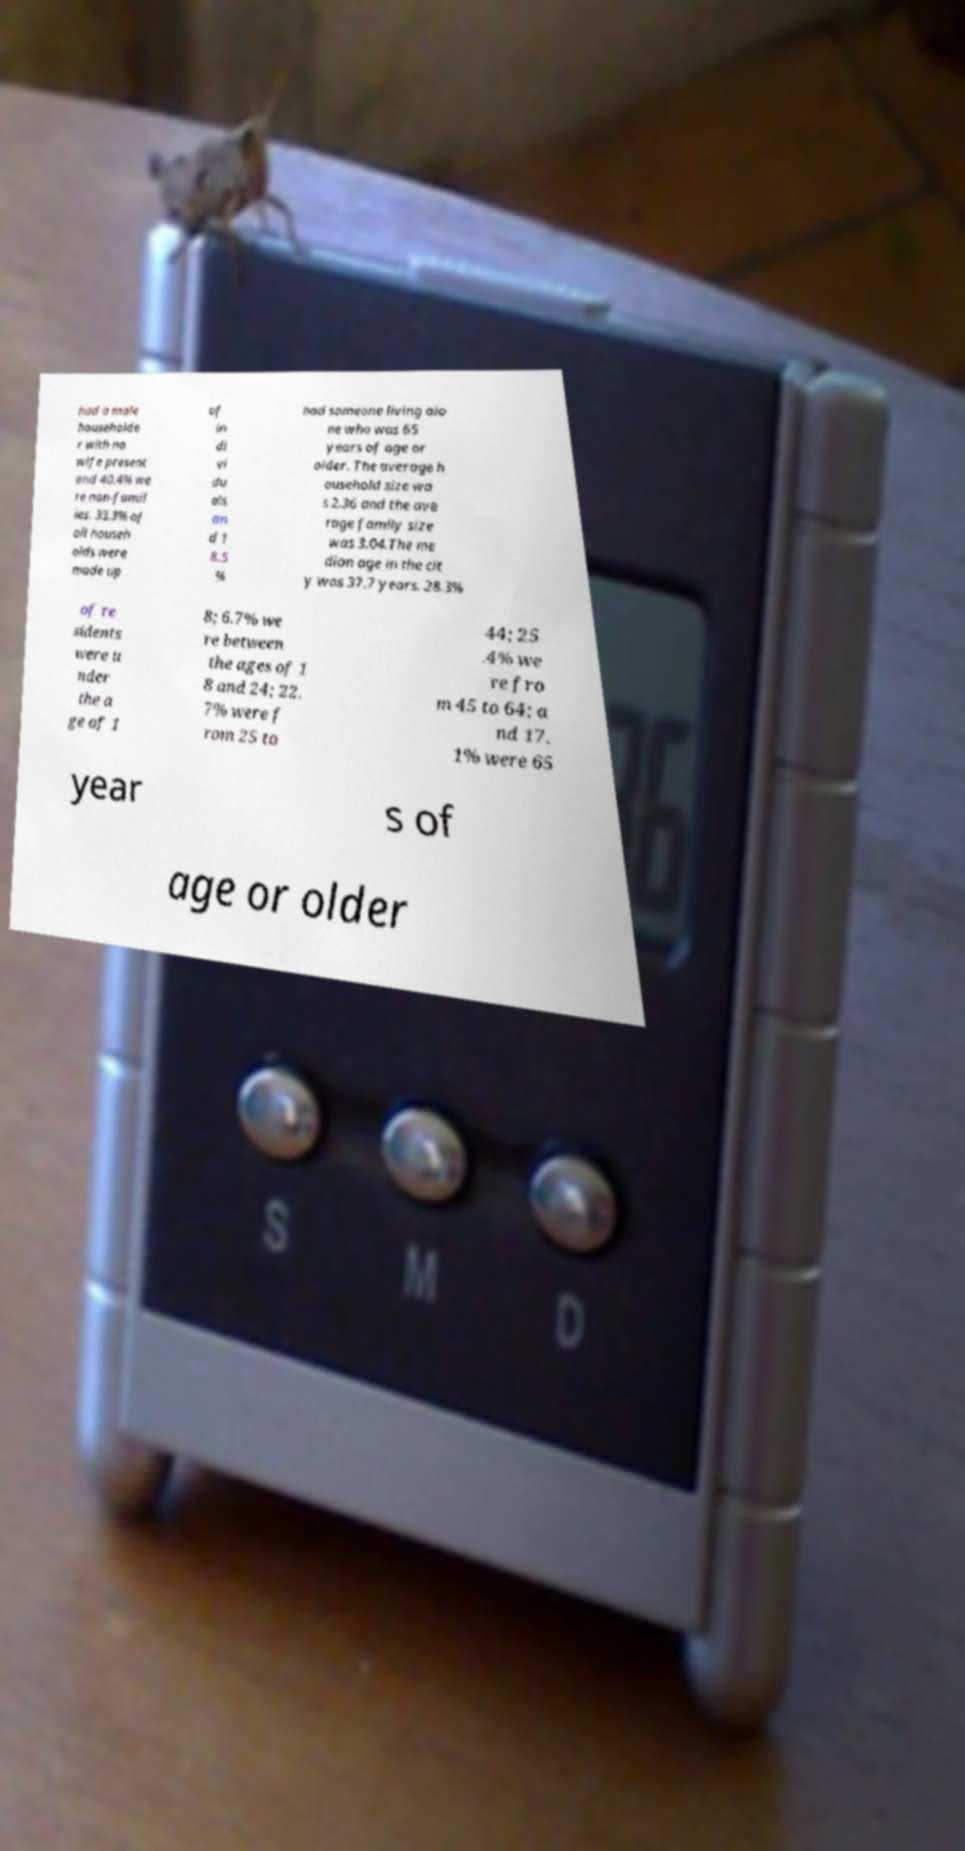I need the written content from this picture converted into text. Can you do that? had a male householde r with no wife present and 40.4% we re non-famil ies. 33.3% of all househ olds were made up of in di vi du als an d 1 8.5 % had someone living alo ne who was 65 years of age or older. The average h ousehold size wa s 2.36 and the ave rage family size was 3.04.The me dian age in the cit y was 37.7 years. 28.3% of re sidents were u nder the a ge of 1 8; 6.7% we re between the ages of 1 8 and 24; 22. 7% were f rom 25 to 44; 25 .4% we re fro m 45 to 64; a nd 17. 1% were 65 year s of age or older 